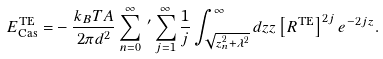<formula> <loc_0><loc_0><loc_500><loc_500>E _ { \text {Cas} } ^ { \text {TE} } = & - \frac { k _ { B } T A } { 2 \pi d ^ { 2 } } \sum _ { n = 0 } ^ { \infty } \, ^ { \prime } \sum _ { j = 1 } ^ { \infty } \frac { 1 } { j } \int _ { \sqrt { z _ { n } ^ { 2 } + \lambda ^ { 2 } } } ^ { \infty } d z z \left [ R ^ { \text {TE} } \right ] ^ { 2 j } e ^ { - 2 j z } .</formula> 